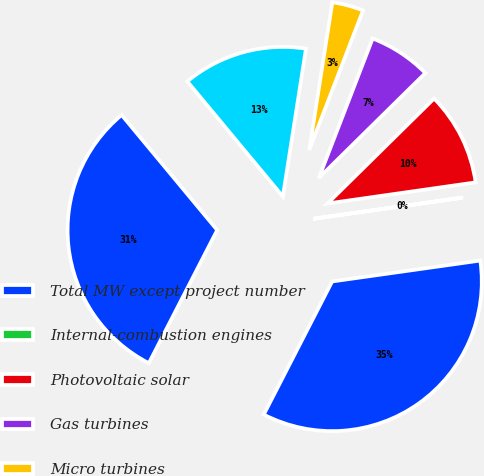Convert chart. <chart><loc_0><loc_0><loc_500><loc_500><pie_chart><fcel>Total MW except project number<fcel>Internal-combustion engines<fcel>Photovoltaic solar<fcel>Gas turbines<fcel>Micro turbines<fcel>Total distribution-level DG<fcel>Number of DG projects<nl><fcel>34.79%<fcel>0.02%<fcel>10.13%<fcel>6.76%<fcel>3.39%<fcel>13.5%<fcel>31.42%<nl></chart> 